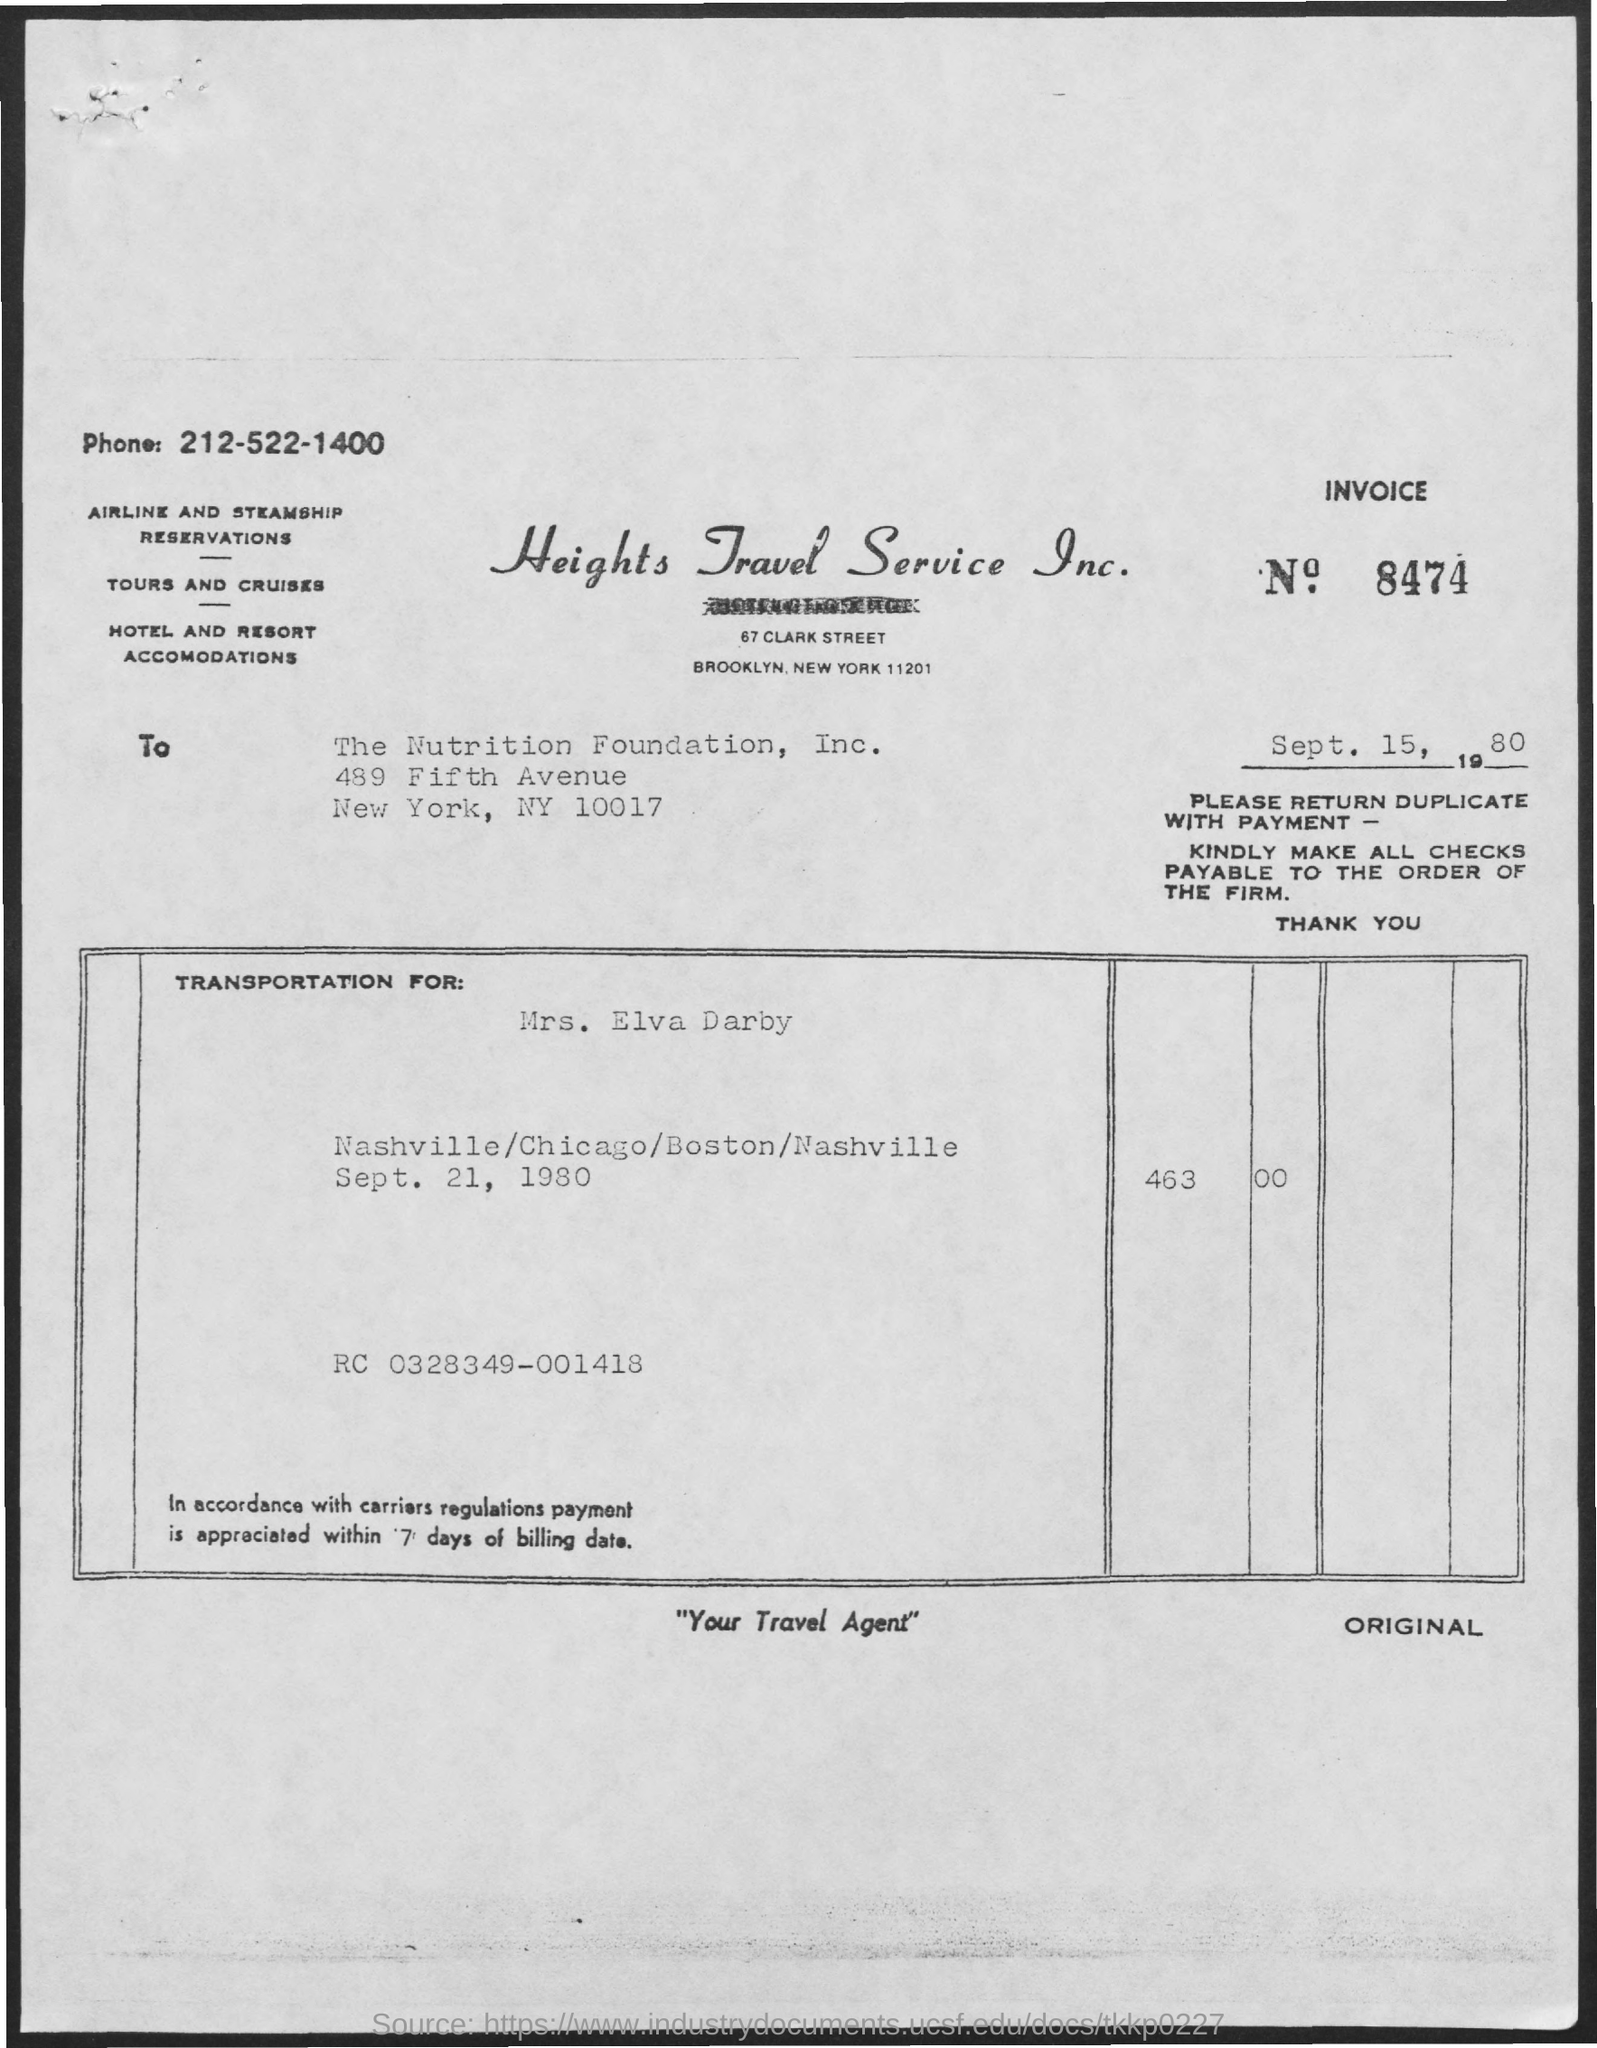Point out several critical features in this image. The phone number mentioned in the document is 212-522-1400. Please provide the invoice number, which is 8474... The title of the document is 'What is the title of the document? heights travel service inc...'. 